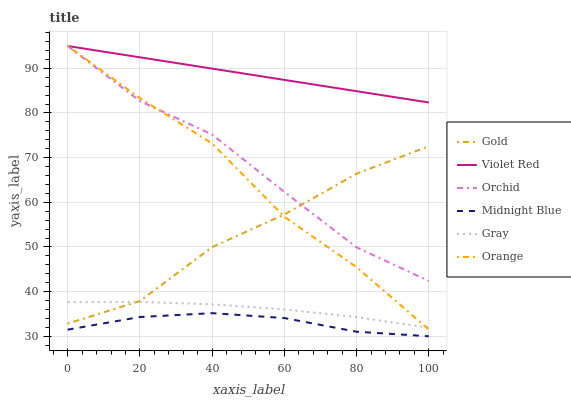Does Midnight Blue have the minimum area under the curve?
Answer yes or no. Yes. Does Violet Red have the maximum area under the curve?
Answer yes or no. Yes. Does Violet Red have the minimum area under the curve?
Answer yes or no. No. Does Midnight Blue have the maximum area under the curve?
Answer yes or no. No. Is Violet Red the smoothest?
Answer yes or no. Yes. Is Gold the roughest?
Answer yes or no. Yes. Is Midnight Blue the smoothest?
Answer yes or no. No. Is Midnight Blue the roughest?
Answer yes or no. No. Does Midnight Blue have the lowest value?
Answer yes or no. Yes. Does Violet Red have the lowest value?
Answer yes or no. No. Does Orchid have the highest value?
Answer yes or no. Yes. Does Midnight Blue have the highest value?
Answer yes or no. No. Is Gray less than Orchid?
Answer yes or no. Yes. Is Orchid greater than Midnight Blue?
Answer yes or no. Yes. Does Violet Red intersect Orange?
Answer yes or no. Yes. Is Violet Red less than Orange?
Answer yes or no. No. Is Violet Red greater than Orange?
Answer yes or no. No. Does Gray intersect Orchid?
Answer yes or no. No. 